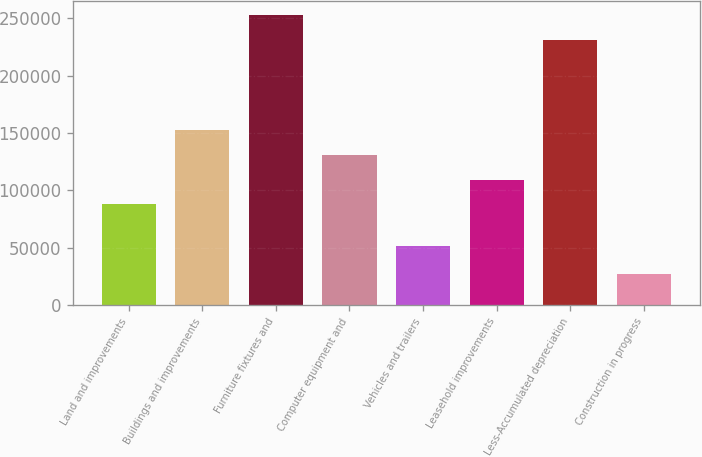Convert chart to OTSL. <chart><loc_0><loc_0><loc_500><loc_500><bar_chart><fcel>Land and improvements<fcel>Buildings and improvements<fcel>Furniture fixtures and<fcel>Computer equipment and<fcel>Vehicles and trailers<fcel>Leasehold improvements<fcel>Less-Accumulated depreciation<fcel>Construction in progress<nl><fcel>87720<fcel>152749<fcel>252806<fcel>131073<fcel>51187<fcel>109396<fcel>231130<fcel>26801<nl></chart> 